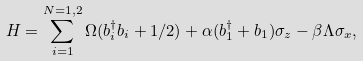Convert formula to latex. <formula><loc_0><loc_0><loc_500><loc_500>H = \sum _ { i = 1 } ^ { N = 1 , 2 } \Omega ( b _ { i } ^ { \dag } b _ { i } + 1 / 2 ) + \alpha ( b _ { 1 } ^ { \dag } + b _ { 1 } ) \sigma _ { z } - \beta \Lambda \sigma _ { x } ,</formula> 